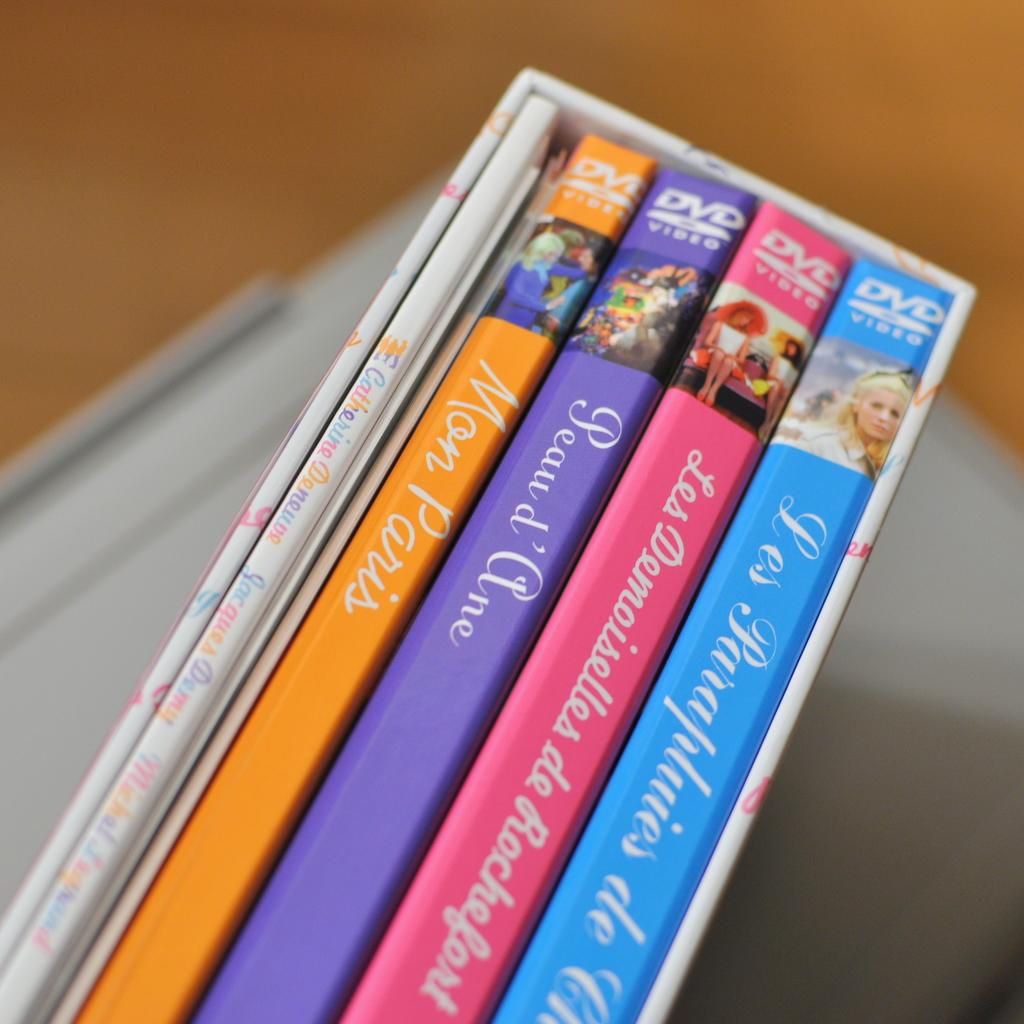<image>
Offer a succinct explanation of the picture presented. A French DVD set with a DVS named Mon Pairs. 